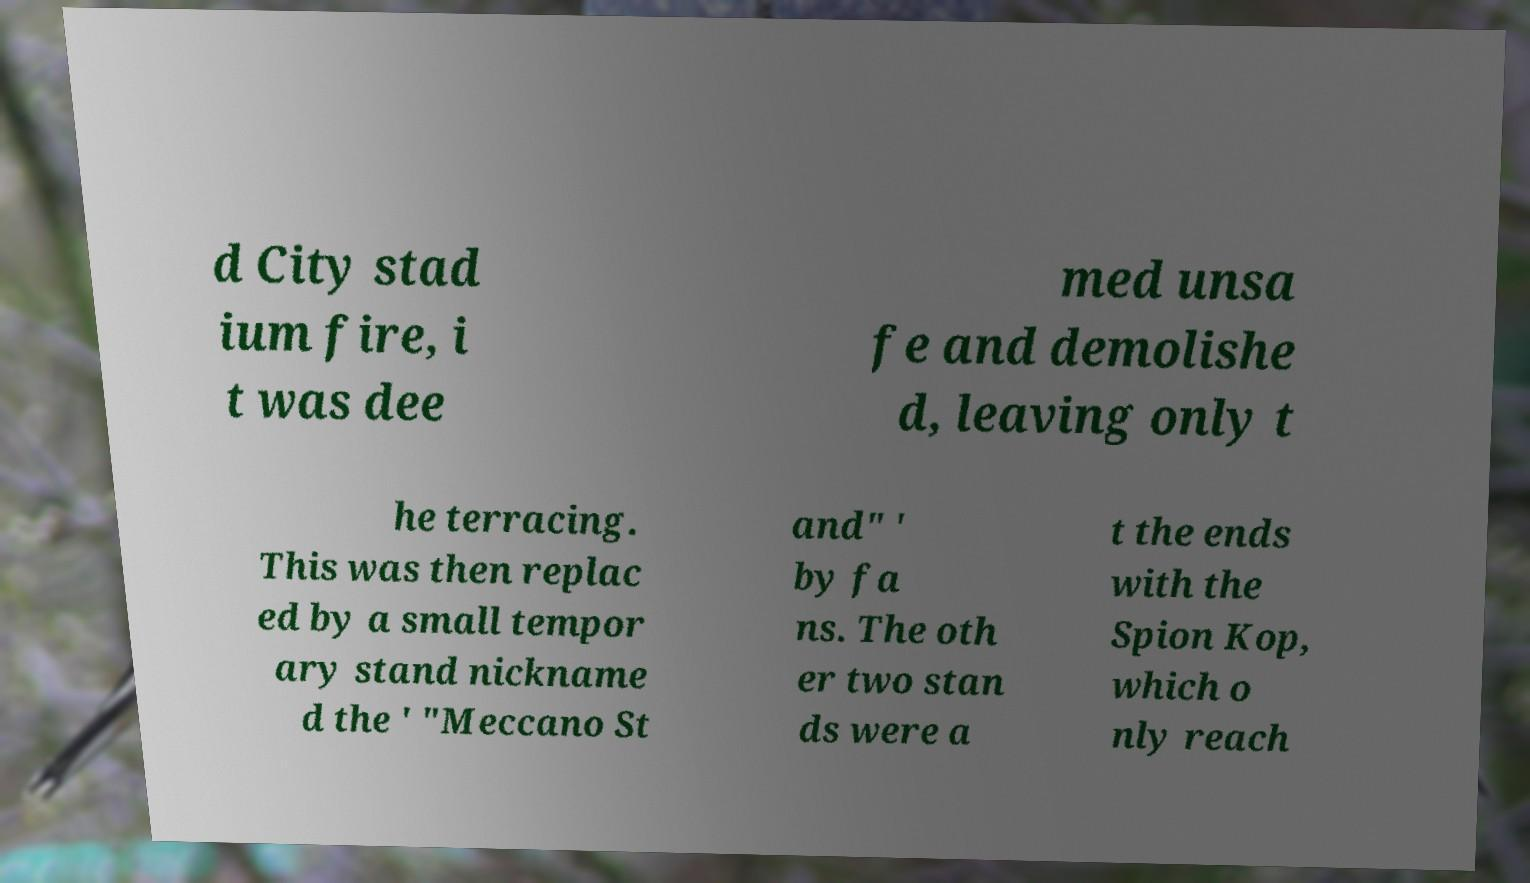What messages or text are displayed in this image? I need them in a readable, typed format. d City stad ium fire, i t was dee med unsa fe and demolishe d, leaving only t he terracing. This was then replac ed by a small tempor ary stand nickname d the ' "Meccano St and" ' by fa ns. The oth er two stan ds were a t the ends with the Spion Kop, which o nly reach 